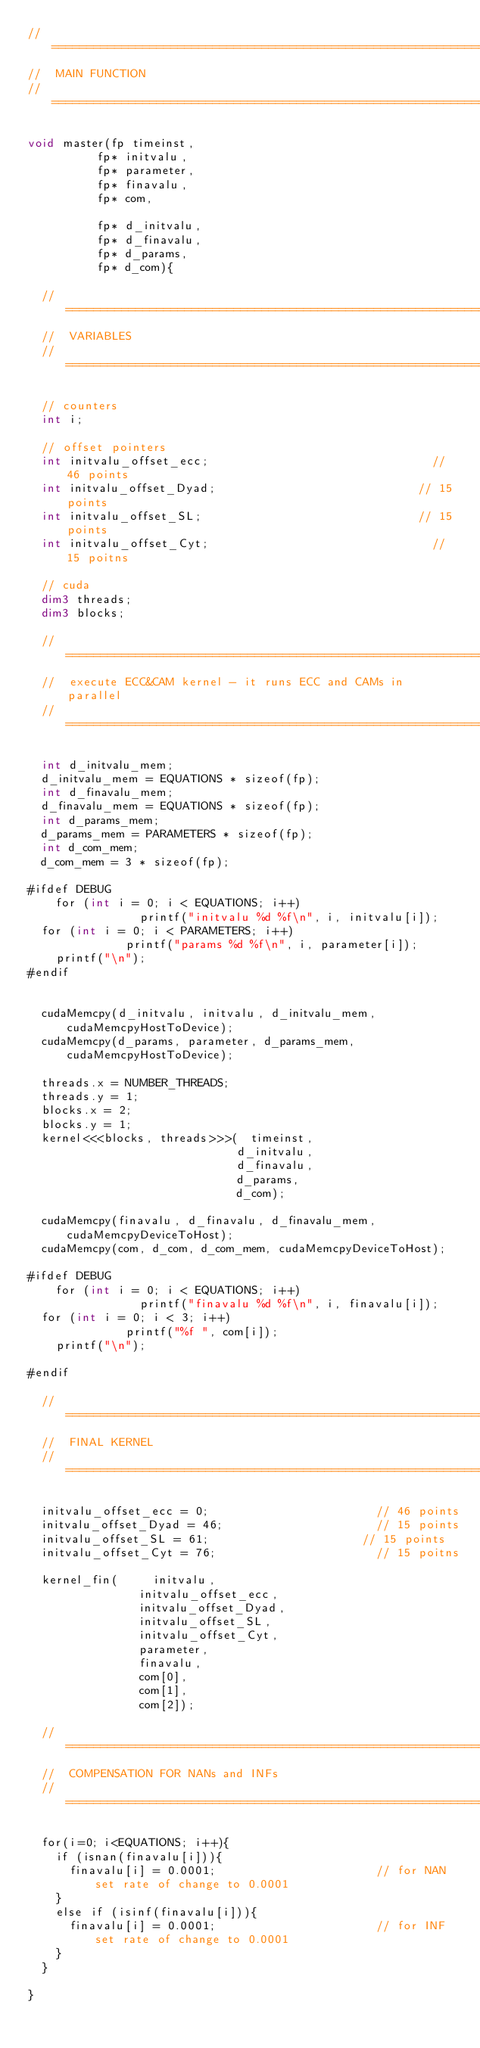<code> <loc_0><loc_0><loc_500><loc_500><_Cuda_>//=====================================================================
//	MAIN FUNCTION
//=====================================================================

void master(fp timeinst,
					fp* initvalu,
					fp* parameter,
					fp* finavalu,
					fp* com,

					fp* d_initvalu,
					fp* d_finavalu,
					fp* d_params,
					fp* d_com){

	//=====================================================================
	//	VARIABLES
	//=====================================================================

	// counters
	int i;

	// offset pointers
	int initvalu_offset_ecc;																// 46 points
	int initvalu_offset_Dyad;															// 15 points
	int initvalu_offset_SL;																// 15 points
	int initvalu_offset_Cyt;																// 15 poitns

	// cuda
	dim3 threads;
	dim3 blocks;

	//=====================================================================
	//	execute ECC&CAM kernel - it runs ECC and CAMs in parallel
	//=====================================================================

	int d_initvalu_mem;
	d_initvalu_mem = EQUATIONS * sizeof(fp);
	int d_finavalu_mem;
	d_finavalu_mem = EQUATIONS * sizeof(fp);
	int d_params_mem;
	d_params_mem = PARAMETERS * sizeof(fp);
	int d_com_mem;
	d_com_mem = 3 * sizeof(fp);

#ifdef DEBUG
    for (int i = 0; i < EQUATIONS; i++)
                printf("initvalu %d %f\n", i, initvalu[i]);
  for (int i = 0; i < PARAMETERS; i++)
              printf("params %d %f\n", i, parameter[i]);
    printf("\n");
#endif


	cudaMemcpy(d_initvalu, initvalu, d_initvalu_mem, cudaMemcpyHostToDevice);
	cudaMemcpy(d_params, parameter, d_params_mem, cudaMemcpyHostToDevice);

	threads.x = NUMBER_THREADS;
	threads.y = 1;
	blocks.x = 2;
	blocks.y = 1;
	kernel<<<blocks, threads>>>(	timeinst,
															d_initvalu,
															d_finavalu,
															d_params,
															d_com);

	cudaMemcpy(finavalu, d_finavalu, d_finavalu_mem, cudaMemcpyDeviceToHost);
	cudaMemcpy(com, d_com, d_com_mem, cudaMemcpyDeviceToHost);

#ifdef DEBUG
    for (int i = 0; i < EQUATIONS; i++)
                printf("finavalu %d %f\n", i, finavalu[i]);
  for (int i = 0; i < 3; i++)
              printf("%f ", com[i]);
    printf("\n");

#endif

	//=====================================================================
	//	FINAL KERNEL
	//=====================================================================

	initvalu_offset_ecc = 0;												// 46 points
	initvalu_offset_Dyad = 46;											// 15 points
	initvalu_offset_SL = 61;											// 15 points
	initvalu_offset_Cyt = 76;												// 15 poitns

	kernel_fin(			initvalu,
								initvalu_offset_ecc,
								initvalu_offset_Dyad,
								initvalu_offset_SL,
								initvalu_offset_Cyt,
								parameter,
								finavalu,
								com[0],
								com[1],
								com[2]);

	//=====================================================================
	//	COMPENSATION FOR NANs and INFs
	//=====================================================================

	for(i=0; i<EQUATIONS; i++){
		if (isnan(finavalu[i])){ 
			finavalu[i] = 0.0001;												// for NAN set rate of change to 0.0001
		}
		else if (isinf(finavalu[i])){ 
			finavalu[i] = 0.0001;												// for INF set rate of change to 0.0001
		}
	}

}
</code> 